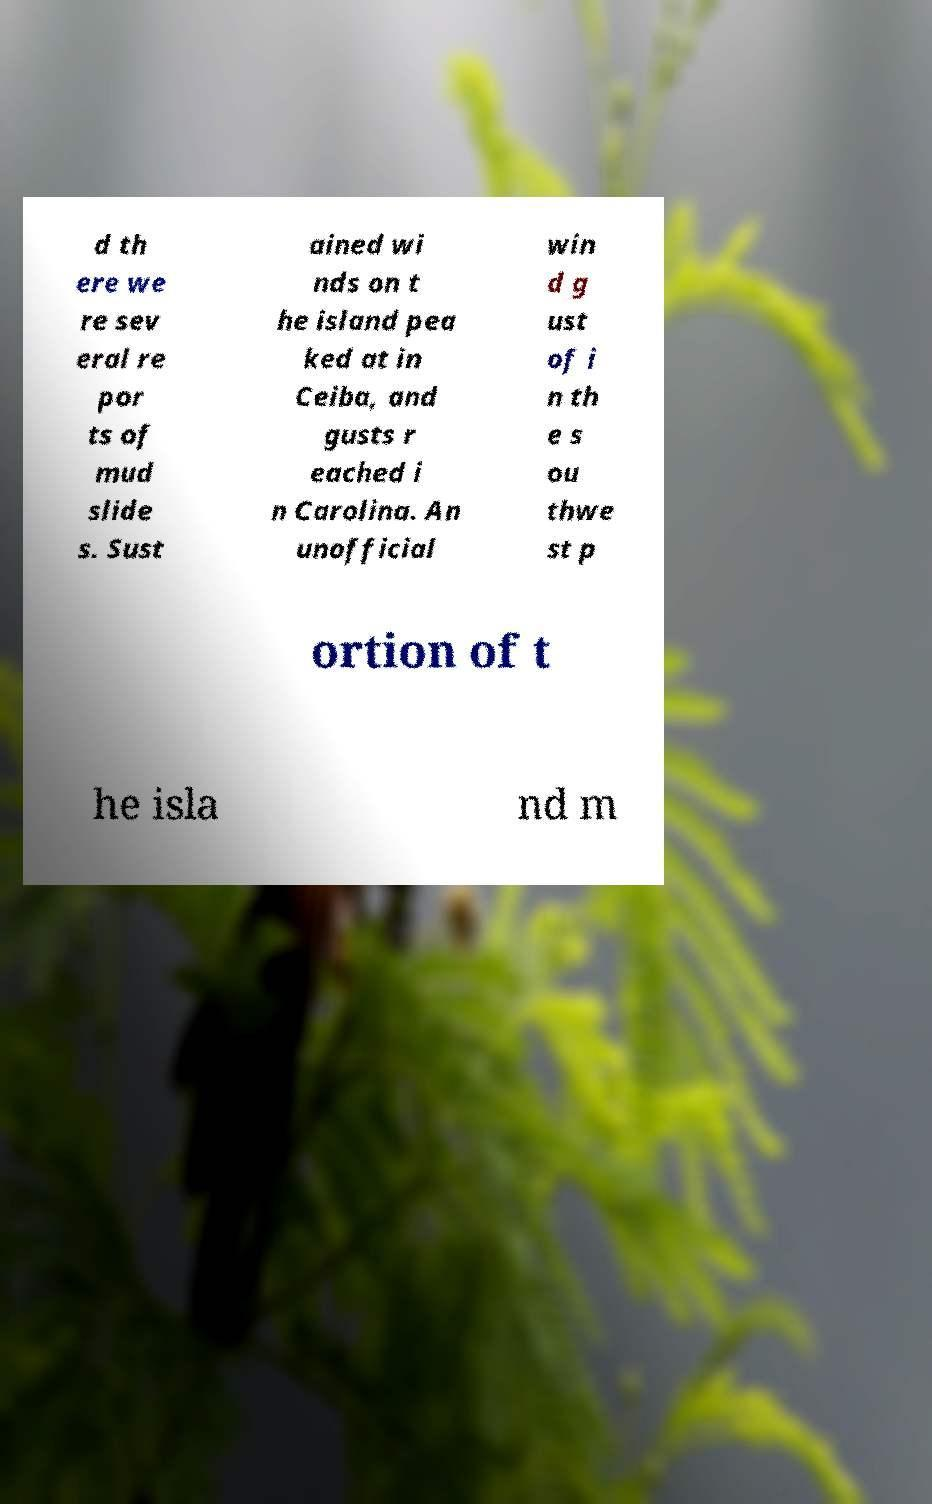Could you extract and type out the text from this image? d th ere we re sev eral re por ts of mud slide s. Sust ained wi nds on t he island pea ked at in Ceiba, and gusts r eached i n Carolina. An unofficial win d g ust of i n th e s ou thwe st p ortion of t he isla nd m 